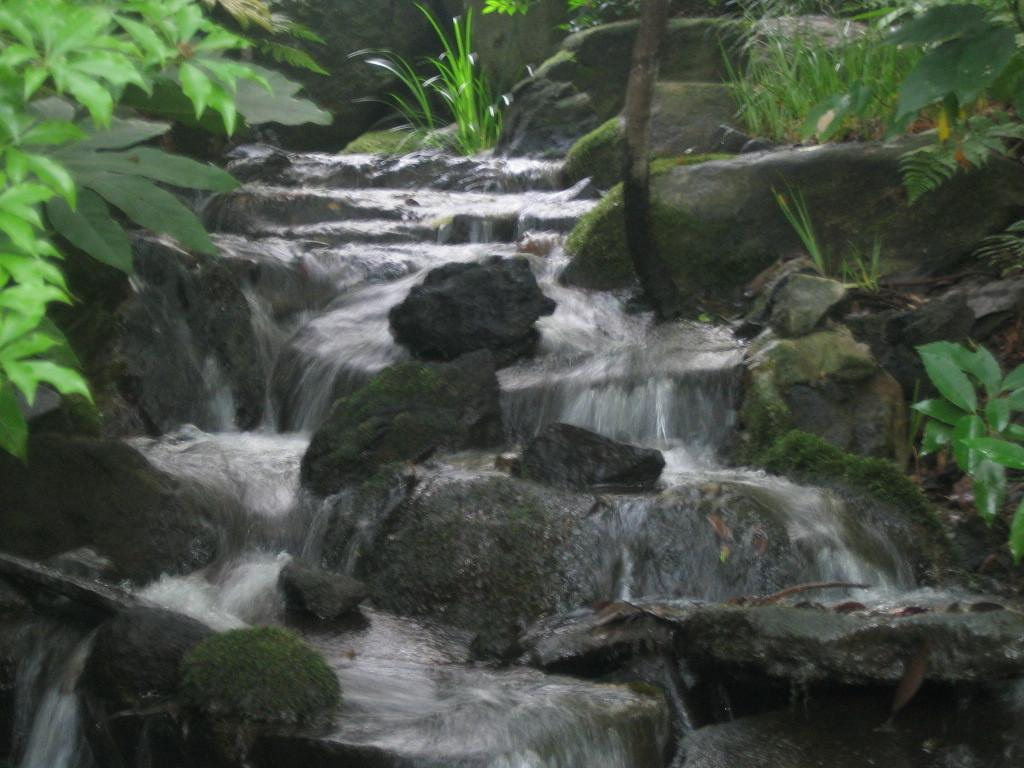What type of natural elements can be seen in the image? There are rocks and water flowing in the image. Where are the plants located in the image? There are plants on both the left and right sides of the image. What type of furniture can be seen in the image? There is no furniture present in the image; it features natural elements such as rocks, water, and plants. 